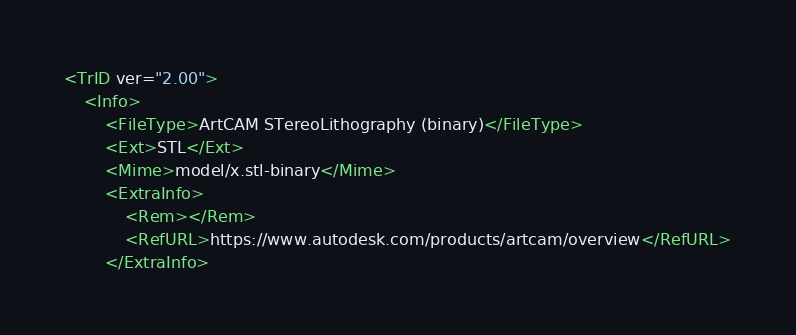Convert code to text. <code><loc_0><loc_0><loc_500><loc_500><_XML_><TrID ver="2.00">
	<Info>
		<FileType>ArtCAM STereoLithography (binary)</FileType>
		<Ext>STL</Ext>
		<Mime>model/x.stl-binary</Mime>
		<ExtraInfo>
			<Rem></Rem>
			<RefURL>https://www.autodesk.com/products/artcam/overview</RefURL>
		</ExtraInfo></code> 